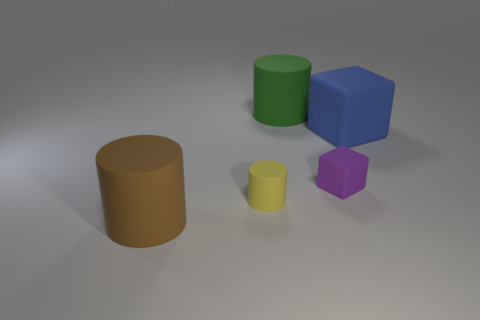Add 1 small yellow rubber blocks. How many objects exist? 6 Subtract all cubes. How many objects are left? 3 Subtract 1 green cylinders. How many objects are left? 4 Subtract all small matte cylinders. Subtract all tiny purple blocks. How many objects are left? 3 Add 1 big green cylinders. How many big green cylinders are left? 2 Add 1 red matte cylinders. How many red matte cylinders exist? 1 